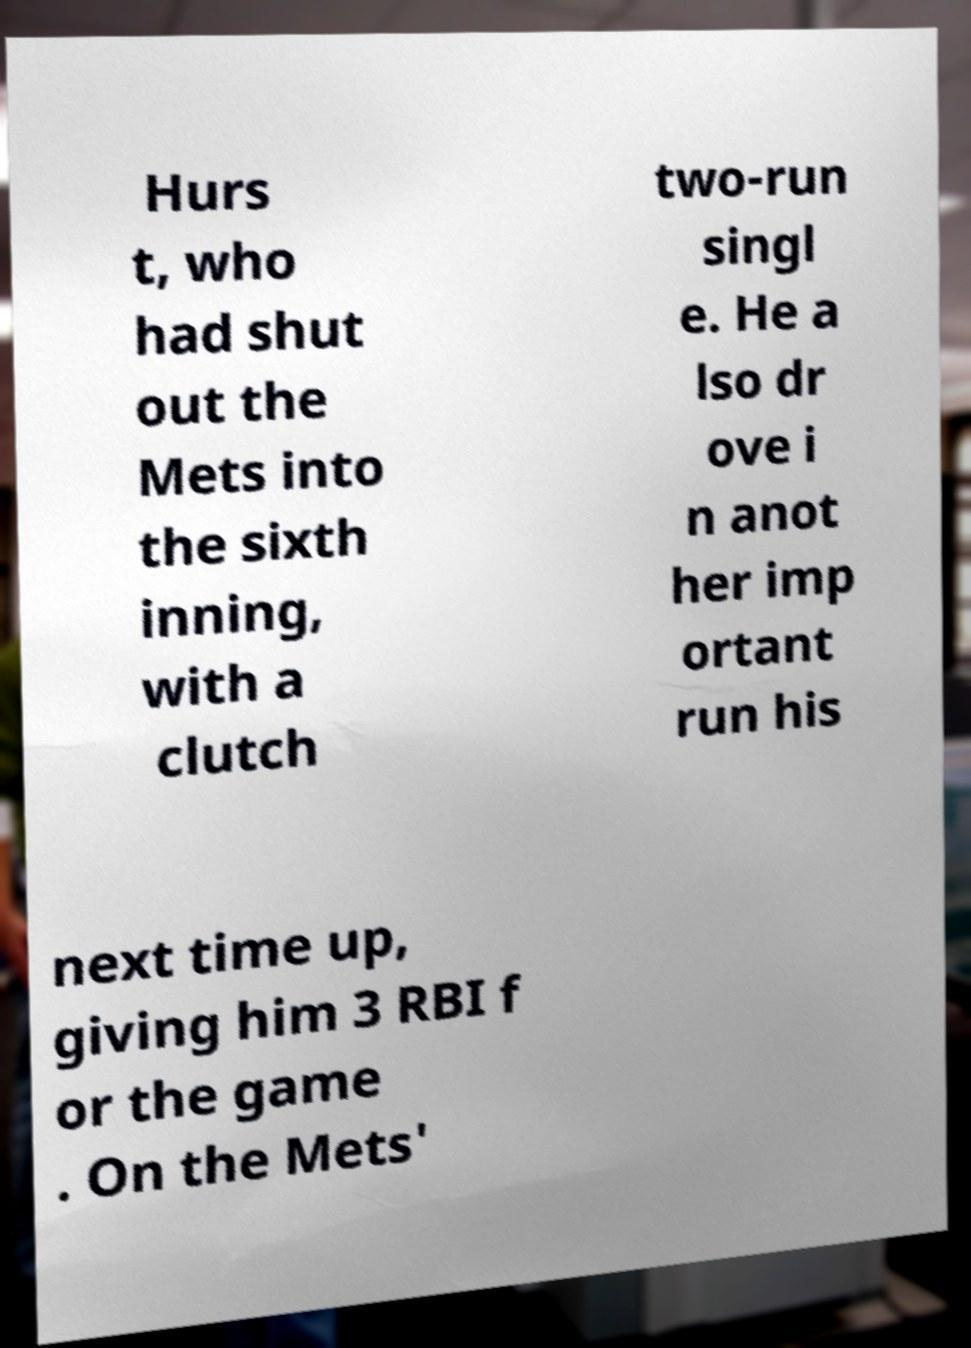Can you accurately transcribe the text from the provided image for me? Hurs t, who had shut out the Mets into the sixth inning, with a clutch two-run singl e. He a lso dr ove i n anot her imp ortant run his next time up, giving him 3 RBI f or the game . On the Mets' 